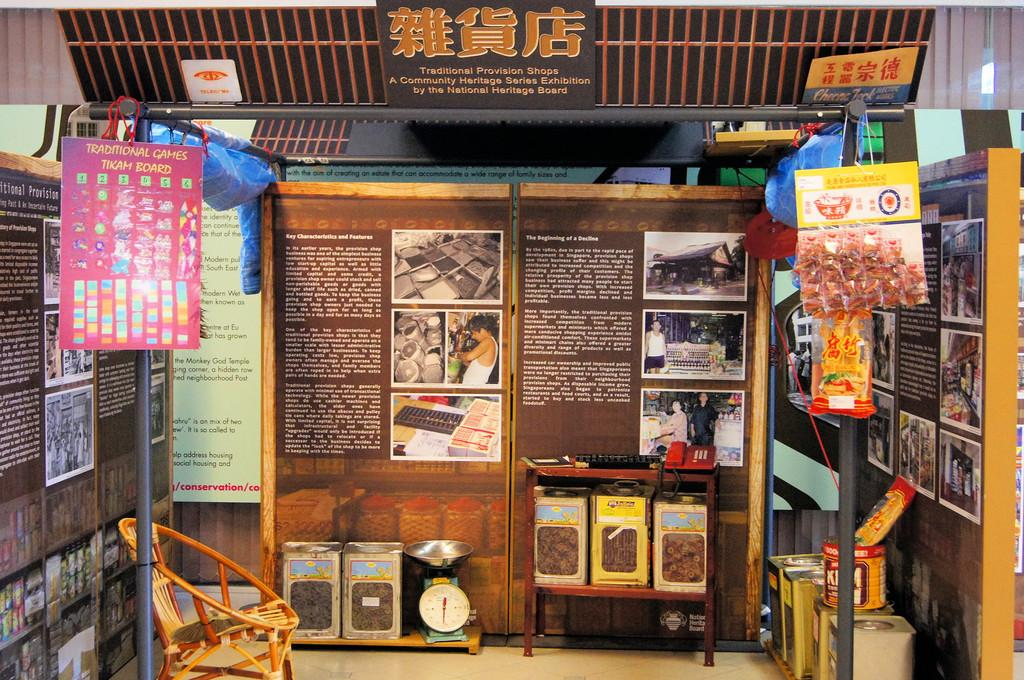<image>
Present a compact description of the photo's key features. A pink poster hanging from the wall reads "Traditional Games Tikam Board" 